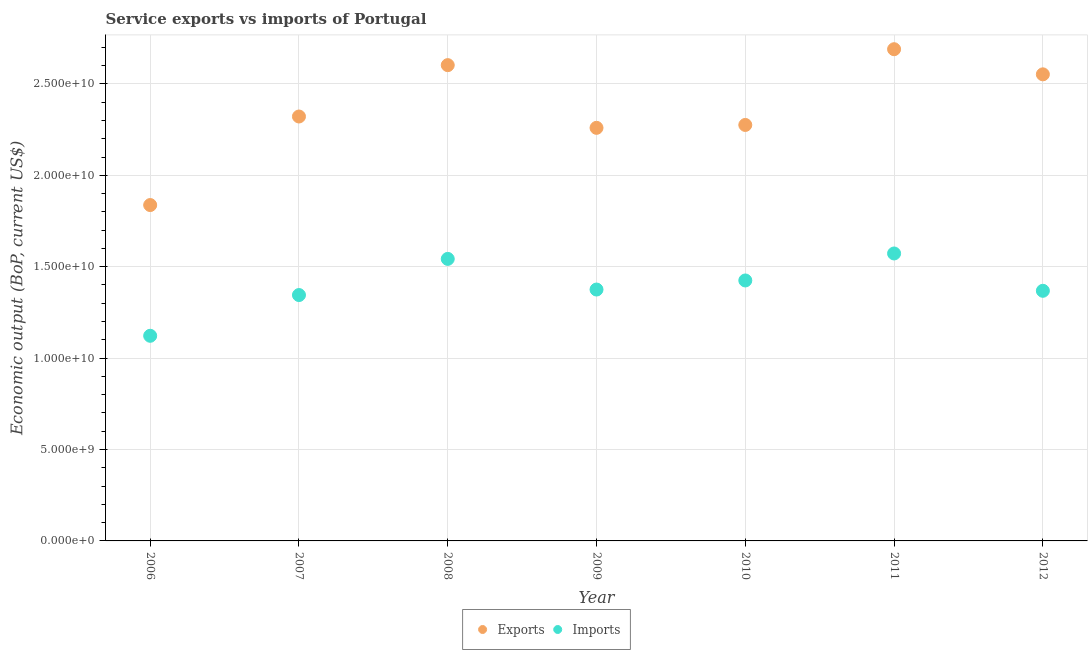What is the amount of service exports in 2012?
Offer a terse response. 2.55e+1. Across all years, what is the maximum amount of service imports?
Your answer should be compact. 1.57e+1. Across all years, what is the minimum amount of service imports?
Your answer should be compact. 1.12e+1. In which year was the amount of service exports maximum?
Give a very brief answer. 2011. What is the total amount of service exports in the graph?
Your answer should be very brief. 1.65e+11. What is the difference between the amount of service imports in 2006 and that in 2012?
Make the answer very short. -2.46e+09. What is the difference between the amount of service exports in 2011 and the amount of service imports in 2007?
Offer a terse response. 1.34e+1. What is the average amount of service exports per year?
Provide a short and direct response. 2.36e+1. In the year 2006, what is the difference between the amount of service exports and amount of service imports?
Your response must be concise. 7.15e+09. What is the ratio of the amount of service exports in 2008 to that in 2010?
Offer a terse response. 1.14. Is the difference between the amount of service imports in 2009 and 2011 greater than the difference between the amount of service exports in 2009 and 2011?
Provide a short and direct response. Yes. What is the difference between the highest and the second highest amount of service exports?
Keep it short and to the point. 8.71e+08. What is the difference between the highest and the lowest amount of service exports?
Provide a short and direct response. 8.52e+09. In how many years, is the amount of service imports greater than the average amount of service imports taken over all years?
Offer a very short reply. 3. Does the amount of service imports monotonically increase over the years?
Offer a terse response. No. Is the amount of service imports strictly greater than the amount of service exports over the years?
Give a very brief answer. No. Is the amount of service exports strictly less than the amount of service imports over the years?
Ensure brevity in your answer.  No. What is the difference between two consecutive major ticks on the Y-axis?
Provide a succinct answer. 5.00e+09. Where does the legend appear in the graph?
Keep it short and to the point. Bottom center. How are the legend labels stacked?
Your response must be concise. Horizontal. What is the title of the graph?
Provide a succinct answer. Service exports vs imports of Portugal. Does "National Visitors" appear as one of the legend labels in the graph?
Provide a short and direct response. No. What is the label or title of the X-axis?
Provide a short and direct response. Year. What is the label or title of the Y-axis?
Offer a terse response. Economic output (BoP, current US$). What is the Economic output (BoP, current US$) of Exports in 2006?
Make the answer very short. 1.84e+1. What is the Economic output (BoP, current US$) of Imports in 2006?
Give a very brief answer. 1.12e+1. What is the Economic output (BoP, current US$) in Exports in 2007?
Provide a short and direct response. 2.32e+1. What is the Economic output (BoP, current US$) in Imports in 2007?
Give a very brief answer. 1.34e+1. What is the Economic output (BoP, current US$) in Exports in 2008?
Make the answer very short. 2.60e+1. What is the Economic output (BoP, current US$) in Imports in 2008?
Provide a short and direct response. 1.54e+1. What is the Economic output (BoP, current US$) in Exports in 2009?
Offer a terse response. 2.26e+1. What is the Economic output (BoP, current US$) in Imports in 2009?
Give a very brief answer. 1.38e+1. What is the Economic output (BoP, current US$) of Exports in 2010?
Offer a very short reply. 2.28e+1. What is the Economic output (BoP, current US$) in Imports in 2010?
Give a very brief answer. 1.42e+1. What is the Economic output (BoP, current US$) in Exports in 2011?
Offer a very short reply. 2.69e+1. What is the Economic output (BoP, current US$) in Imports in 2011?
Your answer should be very brief. 1.57e+1. What is the Economic output (BoP, current US$) in Exports in 2012?
Offer a terse response. 2.55e+1. What is the Economic output (BoP, current US$) of Imports in 2012?
Keep it short and to the point. 1.37e+1. Across all years, what is the maximum Economic output (BoP, current US$) in Exports?
Provide a succinct answer. 2.69e+1. Across all years, what is the maximum Economic output (BoP, current US$) of Imports?
Your response must be concise. 1.57e+1. Across all years, what is the minimum Economic output (BoP, current US$) in Exports?
Provide a succinct answer. 1.84e+1. Across all years, what is the minimum Economic output (BoP, current US$) of Imports?
Make the answer very short. 1.12e+1. What is the total Economic output (BoP, current US$) in Exports in the graph?
Keep it short and to the point. 1.65e+11. What is the total Economic output (BoP, current US$) in Imports in the graph?
Give a very brief answer. 9.75e+1. What is the difference between the Economic output (BoP, current US$) of Exports in 2006 and that in 2007?
Keep it short and to the point. -4.84e+09. What is the difference between the Economic output (BoP, current US$) of Imports in 2006 and that in 2007?
Offer a terse response. -2.23e+09. What is the difference between the Economic output (BoP, current US$) of Exports in 2006 and that in 2008?
Give a very brief answer. -7.65e+09. What is the difference between the Economic output (BoP, current US$) in Imports in 2006 and that in 2008?
Your answer should be compact. -4.21e+09. What is the difference between the Economic output (BoP, current US$) in Exports in 2006 and that in 2009?
Make the answer very short. -4.22e+09. What is the difference between the Economic output (BoP, current US$) in Imports in 2006 and that in 2009?
Your answer should be very brief. -2.53e+09. What is the difference between the Economic output (BoP, current US$) of Exports in 2006 and that in 2010?
Provide a short and direct response. -4.38e+09. What is the difference between the Economic output (BoP, current US$) of Imports in 2006 and that in 2010?
Your answer should be compact. -3.03e+09. What is the difference between the Economic output (BoP, current US$) in Exports in 2006 and that in 2011?
Your answer should be compact. -8.52e+09. What is the difference between the Economic output (BoP, current US$) in Imports in 2006 and that in 2011?
Provide a short and direct response. -4.50e+09. What is the difference between the Economic output (BoP, current US$) in Exports in 2006 and that in 2012?
Ensure brevity in your answer.  -7.15e+09. What is the difference between the Economic output (BoP, current US$) in Imports in 2006 and that in 2012?
Offer a very short reply. -2.46e+09. What is the difference between the Economic output (BoP, current US$) of Exports in 2007 and that in 2008?
Your response must be concise. -2.81e+09. What is the difference between the Economic output (BoP, current US$) of Imports in 2007 and that in 2008?
Ensure brevity in your answer.  -1.98e+09. What is the difference between the Economic output (BoP, current US$) in Exports in 2007 and that in 2009?
Your answer should be compact. 6.20e+08. What is the difference between the Economic output (BoP, current US$) in Imports in 2007 and that in 2009?
Offer a terse response. -3.01e+08. What is the difference between the Economic output (BoP, current US$) of Exports in 2007 and that in 2010?
Offer a terse response. 4.62e+08. What is the difference between the Economic output (BoP, current US$) in Imports in 2007 and that in 2010?
Offer a very short reply. -7.98e+08. What is the difference between the Economic output (BoP, current US$) of Exports in 2007 and that in 2011?
Keep it short and to the point. -3.68e+09. What is the difference between the Economic output (BoP, current US$) of Imports in 2007 and that in 2011?
Provide a short and direct response. -2.27e+09. What is the difference between the Economic output (BoP, current US$) of Exports in 2007 and that in 2012?
Make the answer very short. -2.31e+09. What is the difference between the Economic output (BoP, current US$) in Imports in 2007 and that in 2012?
Offer a very short reply. -2.32e+08. What is the difference between the Economic output (BoP, current US$) of Exports in 2008 and that in 2009?
Give a very brief answer. 3.43e+09. What is the difference between the Economic output (BoP, current US$) in Imports in 2008 and that in 2009?
Make the answer very short. 1.68e+09. What is the difference between the Economic output (BoP, current US$) in Exports in 2008 and that in 2010?
Your answer should be compact. 3.27e+09. What is the difference between the Economic output (BoP, current US$) of Imports in 2008 and that in 2010?
Make the answer very short. 1.18e+09. What is the difference between the Economic output (BoP, current US$) of Exports in 2008 and that in 2011?
Keep it short and to the point. -8.71e+08. What is the difference between the Economic output (BoP, current US$) of Imports in 2008 and that in 2011?
Ensure brevity in your answer.  -2.97e+08. What is the difference between the Economic output (BoP, current US$) of Exports in 2008 and that in 2012?
Keep it short and to the point. 5.03e+08. What is the difference between the Economic output (BoP, current US$) of Imports in 2008 and that in 2012?
Offer a very short reply. 1.74e+09. What is the difference between the Economic output (BoP, current US$) in Exports in 2009 and that in 2010?
Provide a succinct answer. -1.58e+08. What is the difference between the Economic output (BoP, current US$) in Imports in 2009 and that in 2010?
Offer a very short reply. -4.96e+08. What is the difference between the Economic output (BoP, current US$) of Exports in 2009 and that in 2011?
Make the answer very short. -4.30e+09. What is the difference between the Economic output (BoP, current US$) of Imports in 2009 and that in 2011?
Your answer should be compact. -1.97e+09. What is the difference between the Economic output (BoP, current US$) in Exports in 2009 and that in 2012?
Offer a very short reply. -2.93e+09. What is the difference between the Economic output (BoP, current US$) of Imports in 2009 and that in 2012?
Keep it short and to the point. 6.92e+07. What is the difference between the Economic output (BoP, current US$) of Exports in 2010 and that in 2011?
Make the answer very short. -4.14e+09. What is the difference between the Economic output (BoP, current US$) of Imports in 2010 and that in 2011?
Provide a succinct answer. -1.48e+09. What is the difference between the Economic output (BoP, current US$) in Exports in 2010 and that in 2012?
Offer a terse response. -2.77e+09. What is the difference between the Economic output (BoP, current US$) in Imports in 2010 and that in 2012?
Keep it short and to the point. 5.66e+08. What is the difference between the Economic output (BoP, current US$) of Exports in 2011 and that in 2012?
Offer a very short reply. 1.37e+09. What is the difference between the Economic output (BoP, current US$) of Imports in 2011 and that in 2012?
Your response must be concise. 2.04e+09. What is the difference between the Economic output (BoP, current US$) in Exports in 2006 and the Economic output (BoP, current US$) in Imports in 2007?
Provide a short and direct response. 4.92e+09. What is the difference between the Economic output (BoP, current US$) in Exports in 2006 and the Economic output (BoP, current US$) in Imports in 2008?
Provide a short and direct response. 2.95e+09. What is the difference between the Economic output (BoP, current US$) of Exports in 2006 and the Economic output (BoP, current US$) of Imports in 2009?
Make the answer very short. 4.62e+09. What is the difference between the Economic output (BoP, current US$) of Exports in 2006 and the Economic output (BoP, current US$) of Imports in 2010?
Ensure brevity in your answer.  4.12e+09. What is the difference between the Economic output (BoP, current US$) of Exports in 2006 and the Economic output (BoP, current US$) of Imports in 2011?
Your response must be concise. 2.65e+09. What is the difference between the Economic output (BoP, current US$) in Exports in 2006 and the Economic output (BoP, current US$) in Imports in 2012?
Your answer should be very brief. 4.69e+09. What is the difference between the Economic output (BoP, current US$) in Exports in 2007 and the Economic output (BoP, current US$) in Imports in 2008?
Your answer should be very brief. 7.79e+09. What is the difference between the Economic output (BoP, current US$) in Exports in 2007 and the Economic output (BoP, current US$) in Imports in 2009?
Offer a terse response. 9.46e+09. What is the difference between the Economic output (BoP, current US$) of Exports in 2007 and the Economic output (BoP, current US$) of Imports in 2010?
Provide a succinct answer. 8.97e+09. What is the difference between the Economic output (BoP, current US$) of Exports in 2007 and the Economic output (BoP, current US$) of Imports in 2011?
Your response must be concise. 7.49e+09. What is the difference between the Economic output (BoP, current US$) of Exports in 2007 and the Economic output (BoP, current US$) of Imports in 2012?
Your answer should be compact. 9.53e+09. What is the difference between the Economic output (BoP, current US$) of Exports in 2008 and the Economic output (BoP, current US$) of Imports in 2009?
Give a very brief answer. 1.23e+1. What is the difference between the Economic output (BoP, current US$) in Exports in 2008 and the Economic output (BoP, current US$) in Imports in 2010?
Keep it short and to the point. 1.18e+1. What is the difference between the Economic output (BoP, current US$) of Exports in 2008 and the Economic output (BoP, current US$) of Imports in 2011?
Offer a terse response. 1.03e+1. What is the difference between the Economic output (BoP, current US$) in Exports in 2008 and the Economic output (BoP, current US$) in Imports in 2012?
Your answer should be very brief. 1.23e+1. What is the difference between the Economic output (BoP, current US$) of Exports in 2009 and the Economic output (BoP, current US$) of Imports in 2010?
Your answer should be compact. 8.35e+09. What is the difference between the Economic output (BoP, current US$) of Exports in 2009 and the Economic output (BoP, current US$) of Imports in 2011?
Your answer should be very brief. 6.87e+09. What is the difference between the Economic output (BoP, current US$) of Exports in 2009 and the Economic output (BoP, current US$) of Imports in 2012?
Offer a very short reply. 8.91e+09. What is the difference between the Economic output (BoP, current US$) in Exports in 2010 and the Economic output (BoP, current US$) in Imports in 2011?
Your answer should be compact. 7.03e+09. What is the difference between the Economic output (BoP, current US$) of Exports in 2010 and the Economic output (BoP, current US$) of Imports in 2012?
Your answer should be very brief. 9.07e+09. What is the difference between the Economic output (BoP, current US$) in Exports in 2011 and the Economic output (BoP, current US$) in Imports in 2012?
Keep it short and to the point. 1.32e+1. What is the average Economic output (BoP, current US$) of Exports per year?
Ensure brevity in your answer.  2.36e+1. What is the average Economic output (BoP, current US$) of Imports per year?
Make the answer very short. 1.39e+1. In the year 2006, what is the difference between the Economic output (BoP, current US$) of Exports and Economic output (BoP, current US$) of Imports?
Your answer should be compact. 7.15e+09. In the year 2007, what is the difference between the Economic output (BoP, current US$) in Exports and Economic output (BoP, current US$) in Imports?
Give a very brief answer. 9.77e+09. In the year 2008, what is the difference between the Economic output (BoP, current US$) in Exports and Economic output (BoP, current US$) in Imports?
Offer a terse response. 1.06e+1. In the year 2009, what is the difference between the Economic output (BoP, current US$) in Exports and Economic output (BoP, current US$) in Imports?
Offer a very short reply. 8.84e+09. In the year 2010, what is the difference between the Economic output (BoP, current US$) in Exports and Economic output (BoP, current US$) in Imports?
Offer a very short reply. 8.51e+09. In the year 2011, what is the difference between the Economic output (BoP, current US$) of Exports and Economic output (BoP, current US$) of Imports?
Ensure brevity in your answer.  1.12e+1. In the year 2012, what is the difference between the Economic output (BoP, current US$) of Exports and Economic output (BoP, current US$) of Imports?
Keep it short and to the point. 1.18e+1. What is the ratio of the Economic output (BoP, current US$) in Exports in 2006 to that in 2007?
Ensure brevity in your answer.  0.79. What is the ratio of the Economic output (BoP, current US$) of Imports in 2006 to that in 2007?
Give a very brief answer. 0.83. What is the ratio of the Economic output (BoP, current US$) of Exports in 2006 to that in 2008?
Offer a terse response. 0.71. What is the ratio of the Economic output (BoP, current US$) in Imports in 2006 to that in 2008?
Provide a short and direct response. 0.73. What is the ratio of the Economic output (BoP, current US$) of Exports in 2006 to that in 2009?
Your answer should be very brief. 0.81. What is the ratio of the Economic output (BoP, current US$) in Imports in 2006 to that in 2009?
Make the answer very short. 0.82. What is the ratio of the Economic output (BoP, current US$) in Exports in 2006 to that in 2010?
Offer a terse response. 0.81. What is the ratio of the Economic output (BoP, current US$) of Imports in 2006 to that in 2010?
Your answer should be very brief. 0.79. What is the ratio of the Economic output (BoP, current US$) of Exports in 2006 to that in 2011?
Your answer should be very brief. 0.68. What is the ratio of the Economic output (BoP, current US$) in Imports in 2006 to that in 2011?
Offer a terse response. 0.71. What is the ratio of the Economic output (BoP, current US$) in Exports in 2006 to that in 2012?
Give a very brief answer. 0.72. What is the ratio of the Economic output (BoP, current US$) of Imports in 2006 to that in 2012?
Offer a terse response. 0.82. What is the ratio of the Economic output (BoP, current US$) of Exports in 2007 to that in 2008?
Provide a succinct answer. 0.89. What is the ratio of the Economic output (BoP, current US$) of Imports in 2007 to that in 2008?
Provide a succinct answer. 0.87. What is the ratio of the Economic output (BoP, current US$) in Exports in 2007 to that in 2009?
Your answer should be very brief. 1.03. What is the ratio of the Economic output (BoP, current US$) in Imports in 2007 to that in 2009?
Keep it short and to the point. 0.98. What is the ratio of the Economic output (BoP, current US$) in Exports in 2007 to that in 2010?
Give a very brief answer. 1.02. What is the ratio of the Economic output (BoP, current US$) of Imports in 2007 to that in 2010?
Make the answer very short. 0.94. What is the ratio of the Economic output (BoP, current US$) of Exports in 2007 to that in 2011?
Provide a short and direct response. 0.86. What is the ratio of the Economic output (BoP, current US$) of Imports in 2007 to that in 2011?
Make the answer very short. 0.86. What is the ratio of the Economic output (BoP, current US$) in Exports in 2007 to that in 2012?
Ensure brevity in your answer.  0.91. What is the ratio of the Economic output (BoP, current US$) of Imports in 2007 to that in 2012?
Give a very brief answer. 0.98. What is the ratio of the Economic output (BoP, current US$) in Exports in 2008 to that in 2009?
Keep it short and to the point. 1.15. What is the ratio of the Economic output (BoP, current US$) in Imports in 2008 to that in 2009?
Your answer should be very brief. 1.12. What is the ratio of the Economic output (BoP, current US$) in Exports in 2008 to that in 2010?
Make the answer very short. 1.14. What is the ratio of the Economic output (BoP, current US$) of Imports in 2008 to that in 2010?
Give a very brief answer. 1.08. What is the ratio of the Economic output (BoP, current US$) in Exports in 2008 to that in 2011?
Keep it short and to the point. 0.97. What is the ratio of the Economic output (BoP, current US$) in Imports in 2008 to that in 2011?
Ensure brevity in your answer.  0.98. What is the ratio of the Economic output (BoP, current US$) in Exports in 2008 to that in 2012?
Keep it short and to the point. 1.02. What is the ratio of the Economic output (BoP, current US$) of Imports in 2008 to that in 2012?
Your answer should be very brief. 1.13. What is the ratio of the Economic output (BoP, current US$) in Exports in 2009 to that in 2010?
Provide a short and direct response. 0.99. What is the ratio of the Economic output (BoP, current US$) in Imports in 2009 to that in 2010?
Make the answer very short. 0.97. What is the ratio of the Economic output (BoP, current US$) in Exports in 2009 to that in 2011?
Offer a very short reply. 0.84. What is the ratio of the Economic output (BoP, current US$) of Imports in 2009 to that in 2011?
Make the answer very short. 0.87. What is the ratio of the Economic output (BoP, current US$) of Exports in 2009 to that in 2012?
Your response must be concise. 0.89. What is the ratio of the Economic output (BoP, current US$) in Exports in 2010 to that in 2011?
Give a very brief answer. 0.85. What is the ratio of the Economic output (BoP, current US$) in Imports in 2010 to that in 2011?
Offer a very short reply. 0.91. What is the ratio of the Economic output (BoP, current US$) of Exports in 2010 to that in 2012?
Provide a short and direct response. 0.89. What is the ratio of the Economic output (BoP, current US$) in Imports in 2010 to that in 2012?
Provide a succinct answer. 1.04. What is the ratio of the Economic output (BoP, current US$) in Exports in 2011 to that in 2012?
Provide a short and direct response. 1.05. What is the ratio of the Economic output (BoP, current US$) of Imports in 2011 to that in 2012?
Keep it short and to the point. 1.15. What is the difference between the highest and the second highest Economic output (BoP, current US$) in Exports?
Your answer should be very brief. 8.71e+08. What is the difference between the highest and the second highest Economic output (BoP, current US$) of Imports?
Your answer should be very brief. 2.97e+08. What is the difference between the highest and the lowest Economic output (BoP, current US$) of Exports?
Your response must be concise. 8.52e+09. What is the difference between the highest and the lowest Economic output (BoP, current US$) of Imports?
Offer a very short reply. 4.50e+09. 